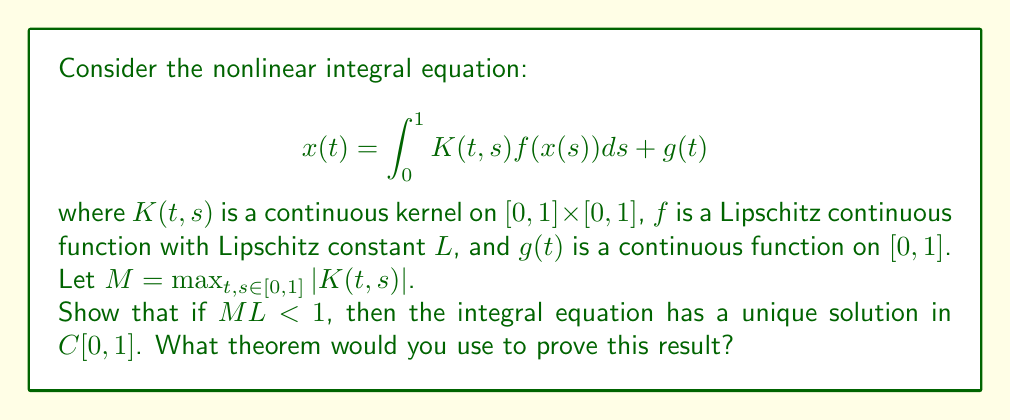Help me with this question. To analyze the stability and uniqueness of the solution, we'll use the Banach Fixed Point Theorem. Here's a step-by-step approach:

1) Define the operator $T: C[0,1] \to C[0,1]$ by:

   $$ (Tx)(t) = \int_0^1 K(t,s) f(x(s)) ds + g(t) $$

2) We need to show that $T$ is a contraction mapping on $C[0,1]$ with the sup norm.

3) Let $x, y \in C[0,1]$. Then:

   $$ \begin{align*}
   |(Tx)(t) - (Ty)(t)| &= \left|\int_0^1 K(t,s)[f(x(s)) - f(y(s))] ds\right| \\
   &\leq \int_0^1 |K(t,s)| |f(x(s)) - f(y(s))| ds \\
   &\leq ML \int_0^1 |x(s) - y(s)| ds \\
   &\leq ML \sup_{s \in [0,1]} |x(s) - y(s)|
   \end{align*} $$

4) Taking the supremum over $t \in [0,1]$:

   $$ \|Tx - Ty\|_\infty \leq ML \|x - y\|_\infty $$

5) Since $ML < 1$ by assumption, $T$ is a contraction mapping.

6) The Banach Fixed Point Theorem states that a contraction mapping on a complete metric space has a unique fixed point.

7) $C[0,1]$ with the sup norm is a complete metric space.

8) Therefore, $T$ has a unique fixed point in $C[0,1]$, which is the unique solution to the integral equation.
Answer: Banach Fixed Point Theorem 